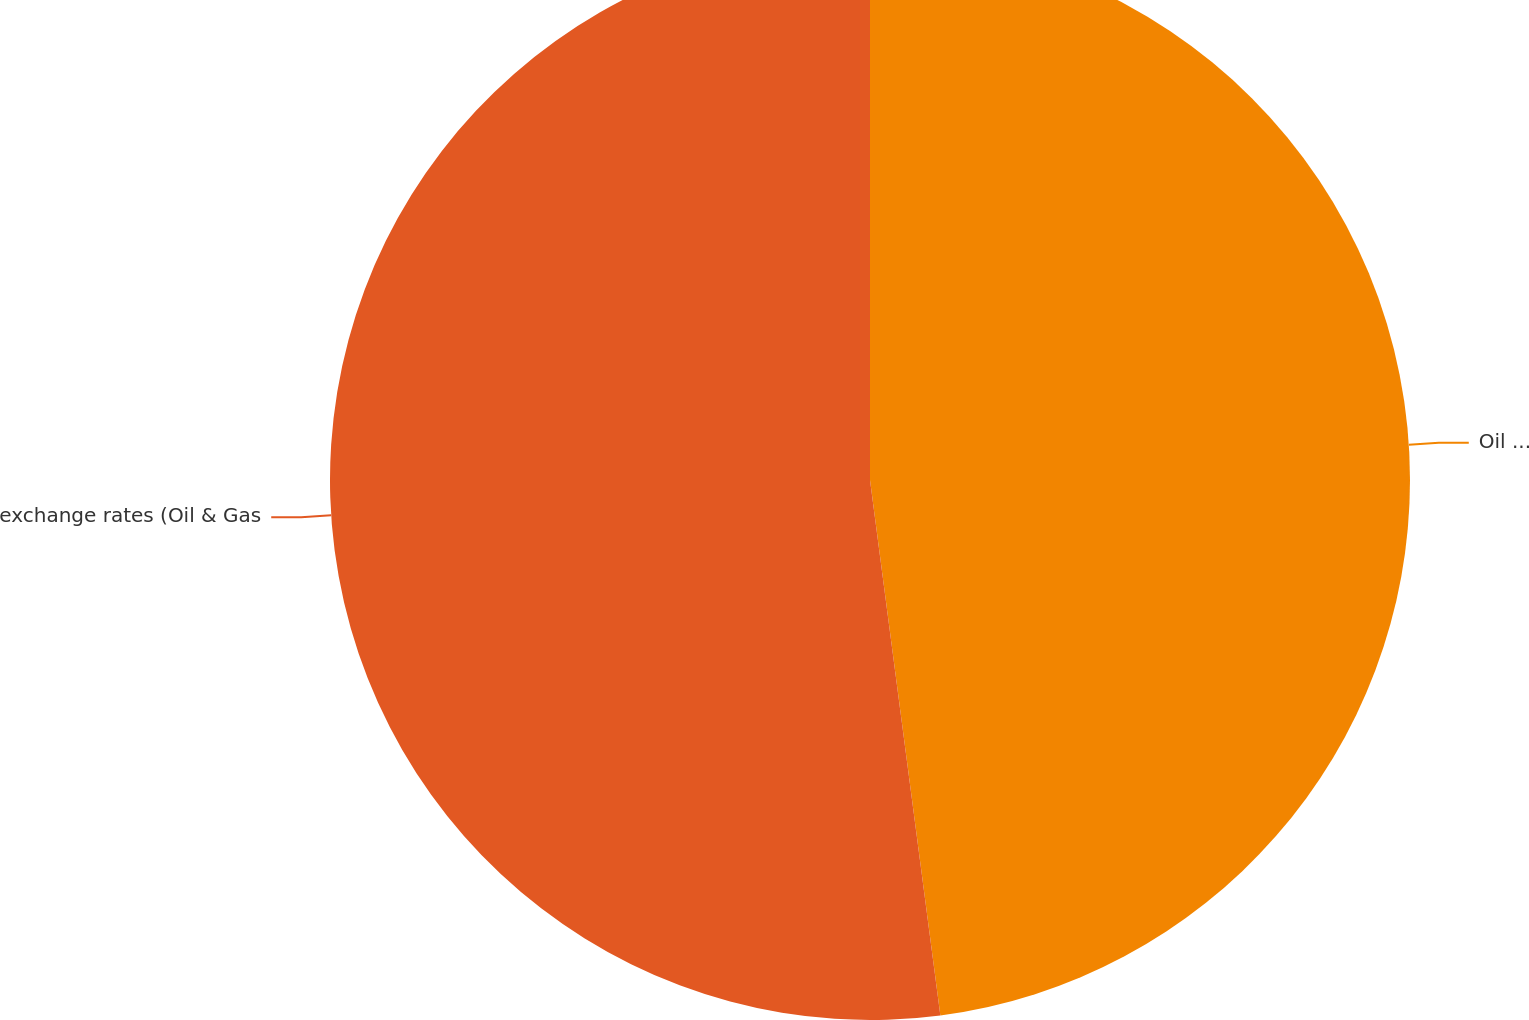Convert chart to OTSL. <chart><loc_0><loc_0><loc_500><loc_500><pie_chart><fcel>Oil & Gas segment revenue<fcel>exchange rates (Oil & Gas<nl><fcel>47.92%<fcel>52.08%<nl></chart> 